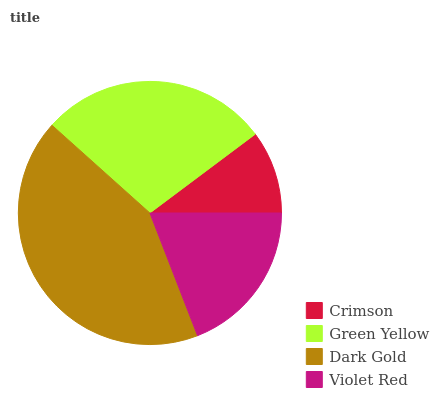Is Crimson the minimum?
Answer yes or no. Yes. Is Dark Gold the maximum?
Answer yes or no. Yes. Is Green Yellow the minimum?
Answer yes or no. No. Is Green Yellow the maximum?
Answer yes or no. No. Is Green Yellow greater than Crimson?
Answer yes or no. Yes. Is Crimson less than Green Yellow?
Answer yes or no. Yes. Is Crimson greater than Green Yellow?
Answer yes or no. No. Is Green Yellow less than Crimson?
Answer yes or no. No. Is Green Yellow the high median?
Answer yes or no. Yes. Is Violet Red the low median?
Answer yes or no. Yes. Is Violet Red the high median?
Answer yes or no. No. Is Crimson the low median?
Answer yes or no. No. 